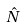Convert formula to latex. <formula><loc_0><loc_0><loc_500><loc_500>\hat { N }</formula> 